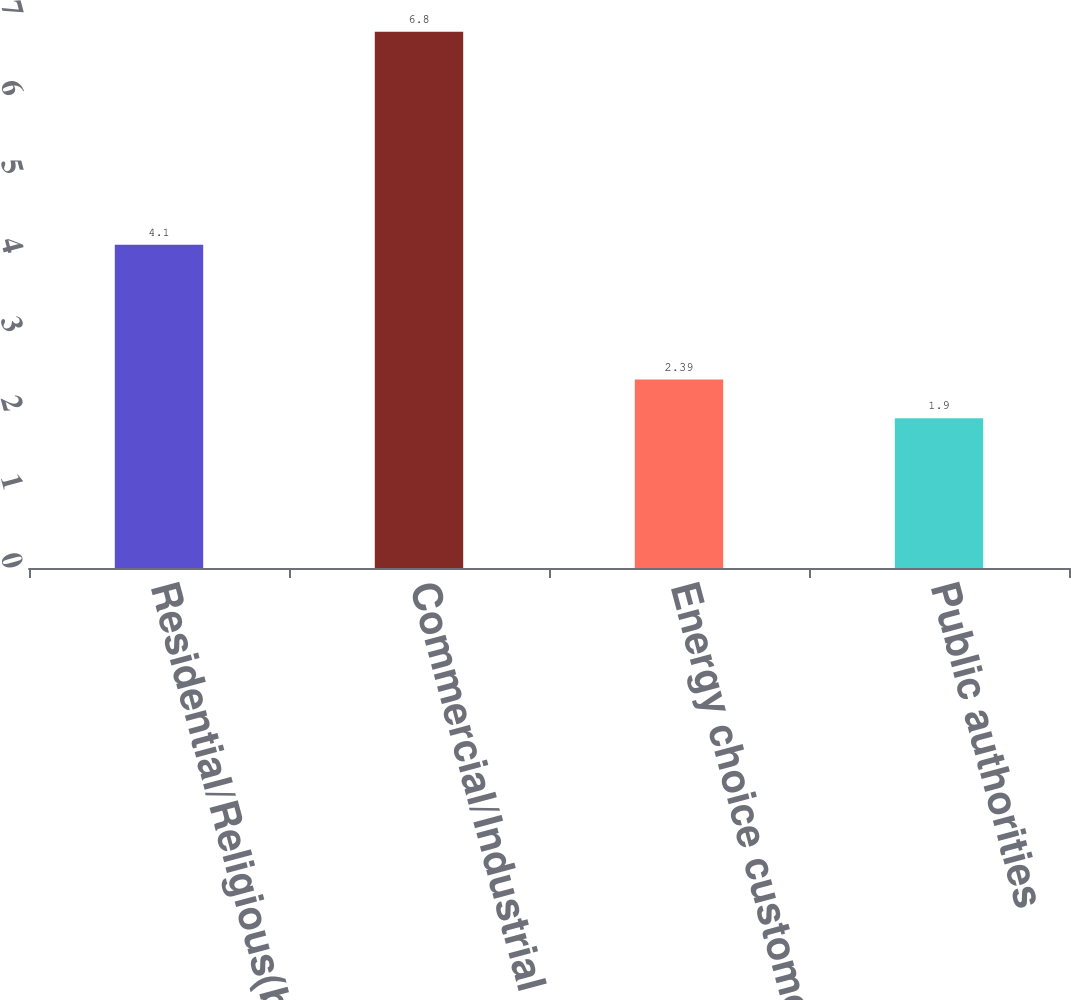Convert chart. <chart><loc_0><loc_0><loc_500><loc_500><bar_chart><fcel>Residential/Religious(b)<fcel>Commercial/Industrial<fcel>Energy choice customers<fcel>Public authorities<nl><fcel>4.1<fcel>6.8<fcel>2.39<fcel>1.9<nl></chart> 